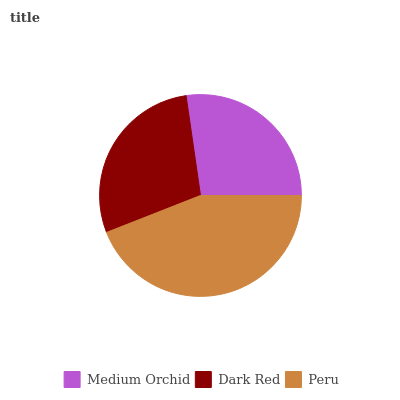Is Medium Orchid the minimum?
Answer yes or no. Yes. Is Peru the maximum?
Answer yes or no. Yes. Is Dark Red the minimum?
Answer yes or no. No. Is Dark Red the maximum?
Answer yes or no. No. Is Dark Red greater than Medium Orchid?
Answer yes or no. Yes. Is Medium Orchid less than Dark Red?
Answer yes or no. Yes. Is Medium Orchid greater than Dark Red?
Answer yes or no. No. Is Dark Red less than Medium Orchid?
Answer yes or no. No. Is Dark Red the high median?
Answer yes or no. Yes. Is Dark Red the low median?
Answer yes or no. Yes. Is Peru the high median?
Answer yes or no. No. Is Medium Orchid the low median?
Answer yes or no. No. 